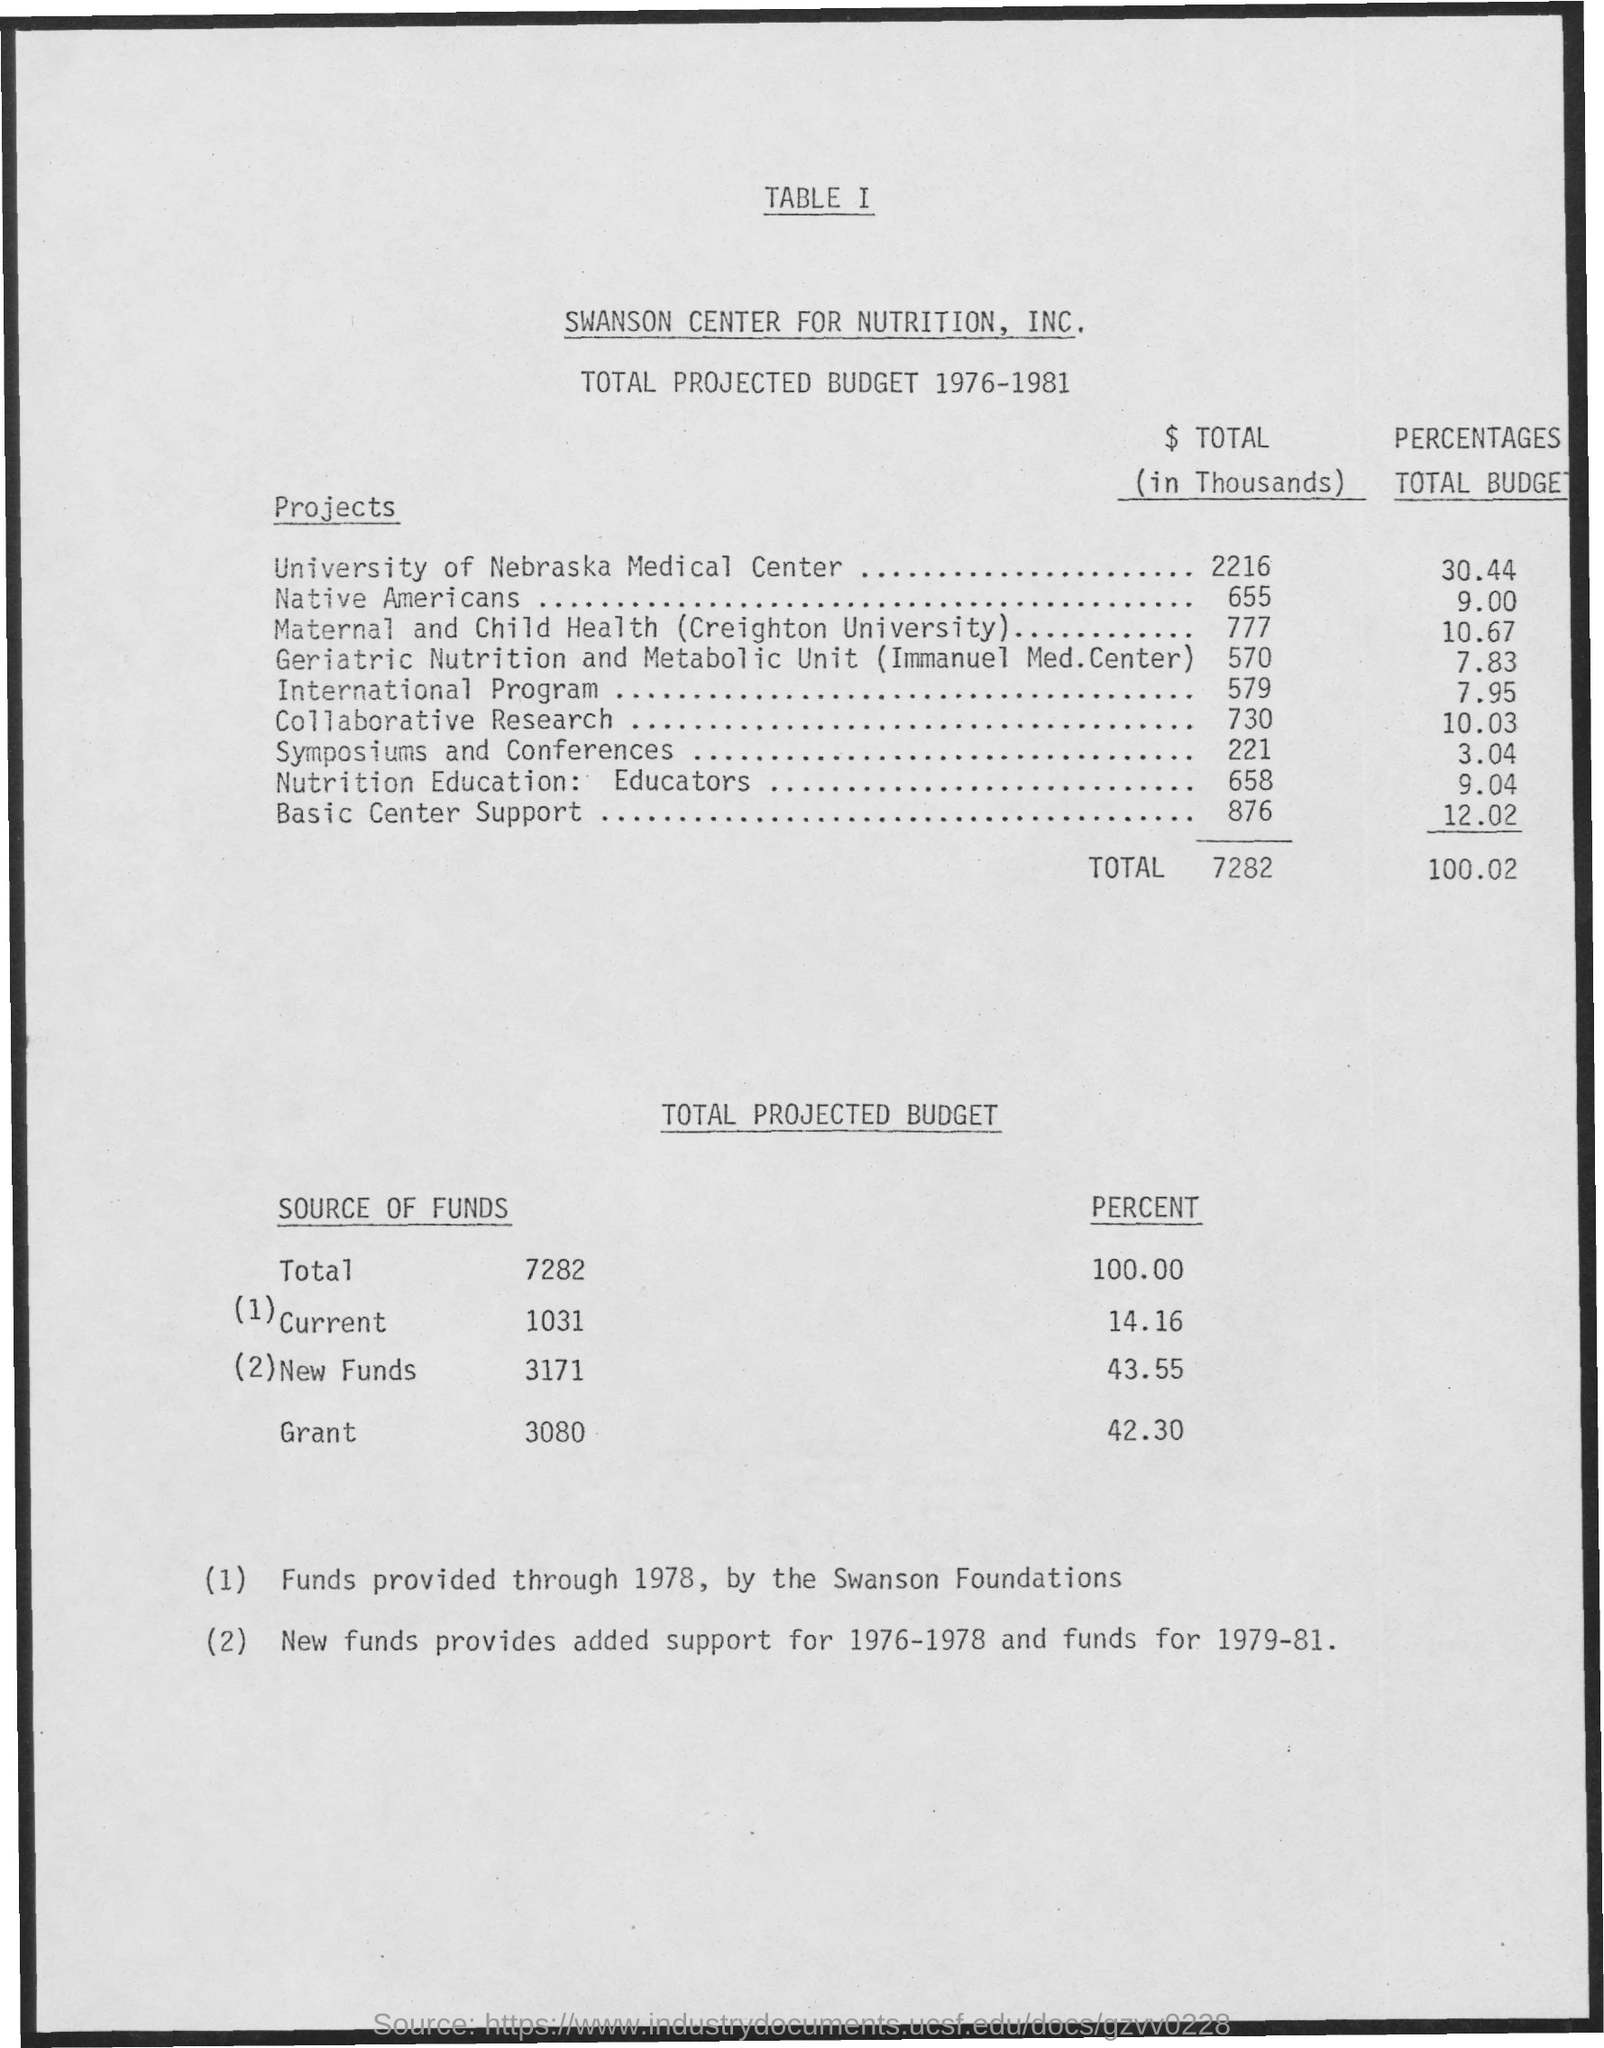What is the percentage of total budget of the project university of nebraska medical center?
Give a very brief answer. 30.44. What is the percentage of total budget of the project native americans?
Your answer should be very brief. 9.00. What is the percentage of total budget of the project international program?
Give a very brief answer. 7.95. What is the percentage of total budget of the project collaborative research?
Your response must be concise. 10.03. What is the percentage of total budget of the project symposiums and conferences?
Provide a succinct answer. 3.04. Who provided funds through 1978?
Your answer should be compact. The swanson foundations. What is the percentage of total budget of the project basic center support?
Your answer should be compact. 12.02. 